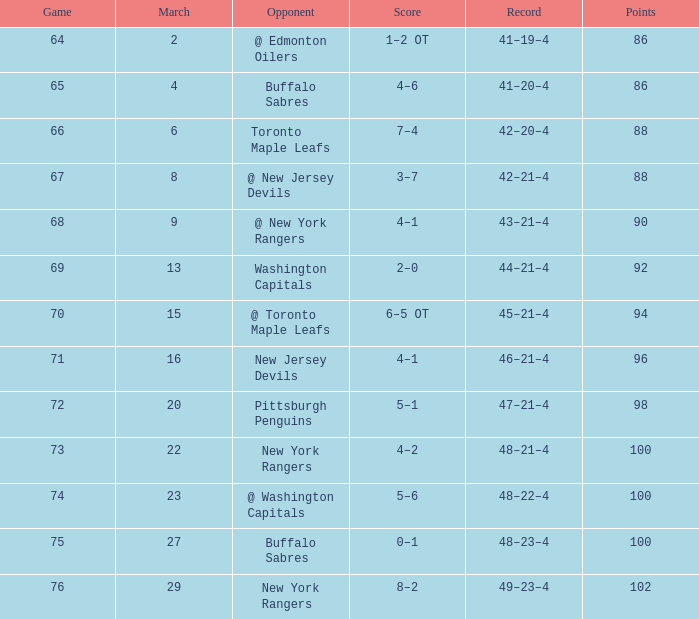Which Points have a Record of 45–21–4, and a Game larger than 70? None. 